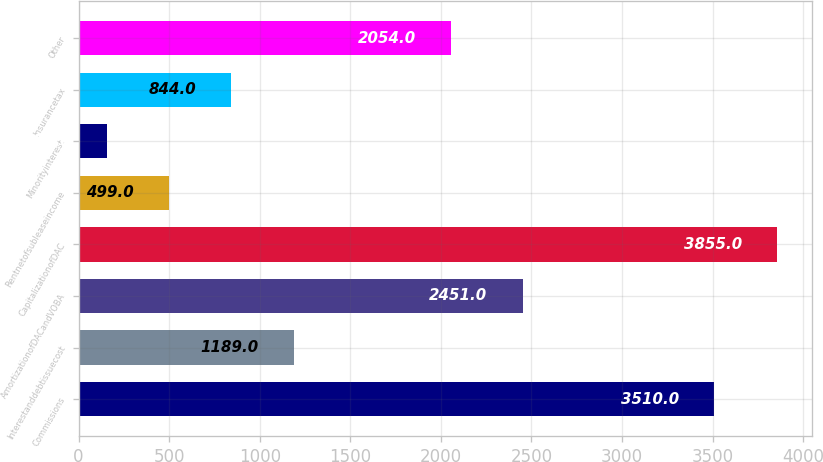Convert chart. <chart><loc_0><loc_0><loc_500><loc_500><bar_chart><fcel>Commissions<fcel>Interestanddebtissuecost<fcel>AmortizationofDACandVOBA<fcel>CapitalizationofDAC<fcel>Rentnetofsubleaseincome<fcel>Minorityinterest<fcel>Insurancetax<fcel>Other<nl><fcel>3510<fcel>1189<fcel>2451<fcel>3855<fcel>499<fcel>154<fcel>844<fcel>2054<nl></chart> 